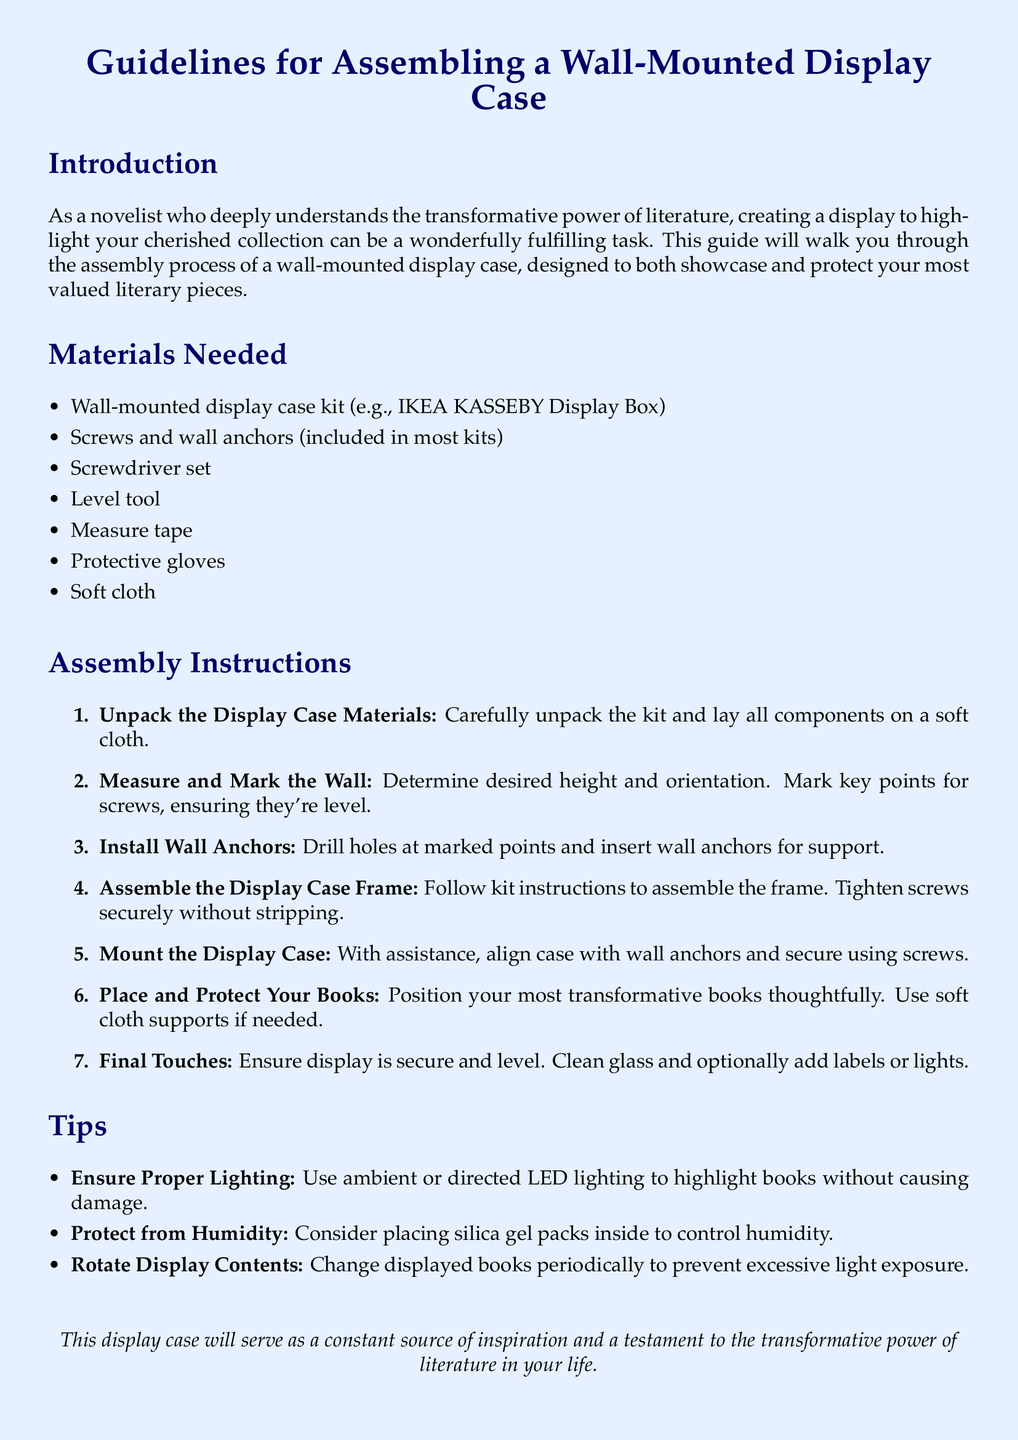What is the title of the document? The title is stated at the beginning of the document and describes the content about assembling a wall-mounted display case.
Answer: Guidelines for Assembling a Wall-Mounted Display Case How many steps are in the assembly instructions? The document enumerates the steps in the assembly instructions section, totaling them at six.
Answer: 7 What tool is recommended for ensuring the display case is level? The document mentions a specific tool that is essential for achieving level alignment during mounting.
Answer: Level tool What is suggested for humidity control inside the display case? The tips section offers advice on managing environmental factors to protect the books inside the display case.
Answer: Silica gel packs What type of lighting is recommended for the display? There is a suggestion in the tips about the kind of lighting to use without causing damage to the books.
Answer: LED lighting What should you do before mounting the display case? The assembly instructions emphasize a critical action required to prepare for secure installation.
Answer: Install wall anchors How should you position your most transformative books? The instructions outline a thoughtful approach for displaying the books, highlighting care during this step.
Answer: Thoughtfully 